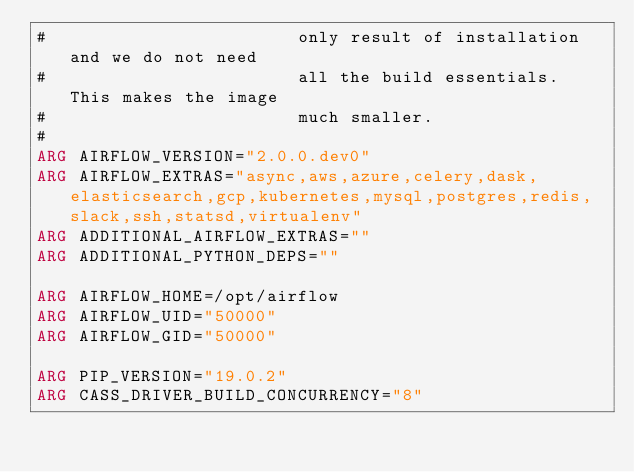Convert code to text. <code><loc_0><loc_0><loc_500><loc_500><_Dockerfile_>#                        only result of installation and we do not need
#                        all the build essentials. This makes the image
#                        much smaller.
#
ARG AIRFLOW_VERSION="2.0.0.dev0"
ARG AIRFLOW_EXTRAS="async,aws,azure,celery,dask,elasticsearch,gcp,kubernetes,mysql,postgres,redis,slack,ssh,statsd,virtualenv"
ARG ADDITIONAL_AIRFLOW_EXTRAS=""
ARG ADDITIONAL_PYTHON_DEPS=""

ARG AIRFLOW_HOME=/opt/airflow
ARG AIRFLOW_UID="50000"
ARG AIRFLOW_GID="50000"

ARG PIP_VERSION="19.0.2"
ARG CASS_DRIVER_BUILD_CONCURRENCY="8"
</code> 